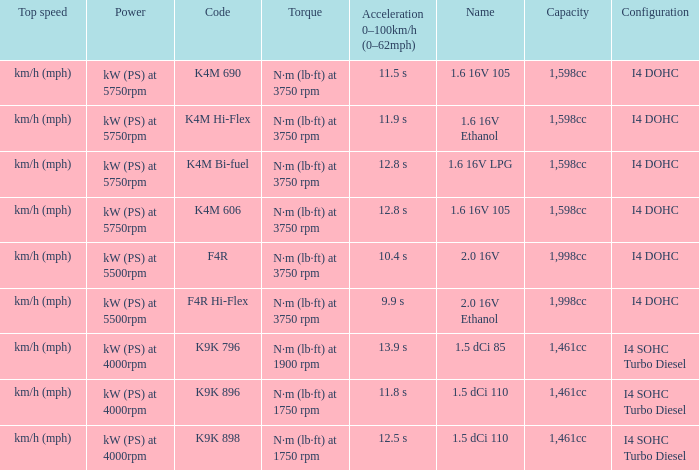What is the code of 1.5 dci 110, which has a capacity of 1,461cc? K9K 896, K9K 898. 